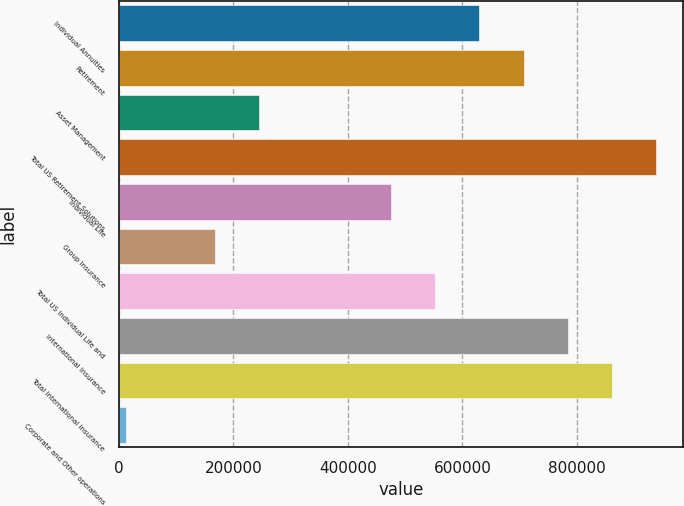Convert chart. <chart><loc_0><loc_0><loc_500><loc_500><bar_chart><fcel>Individual Annuities<fcel>Retirement<fcel>Asset Management<fcel>Total US Retirement Solutions<fcel>Individual Life<fcel>Group Insurance<fcel>Total US Individual Life and<fcel>International Insurance<fcel>Total International Insurance<fcel>Corporate and Other operations<nl><fcel>629770<fcel>706866<fcel>244289<fcel>938154<fcel>475578<fcel>167193<fcel>552674<fcel>783962<fcel>861058<fcel>13001<nl></chart> 